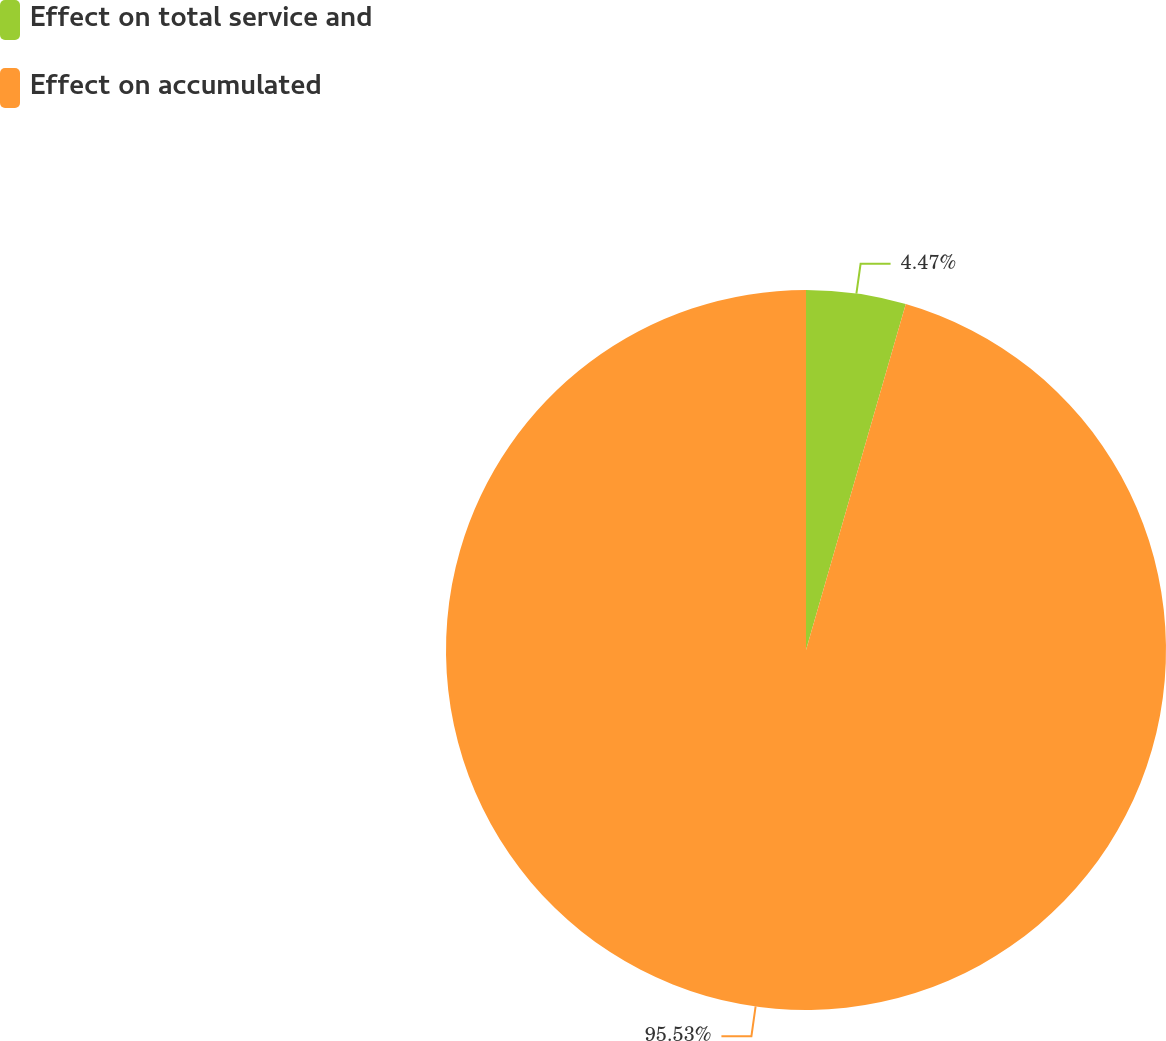<chart> <loc_0><loc_0><loc_500><loc_500><pie_chart><fcel>Effect on total service and<fcel>Effect on accumulated<nl><fcel>4.47%<fcel>95.53%<nl></chart> 